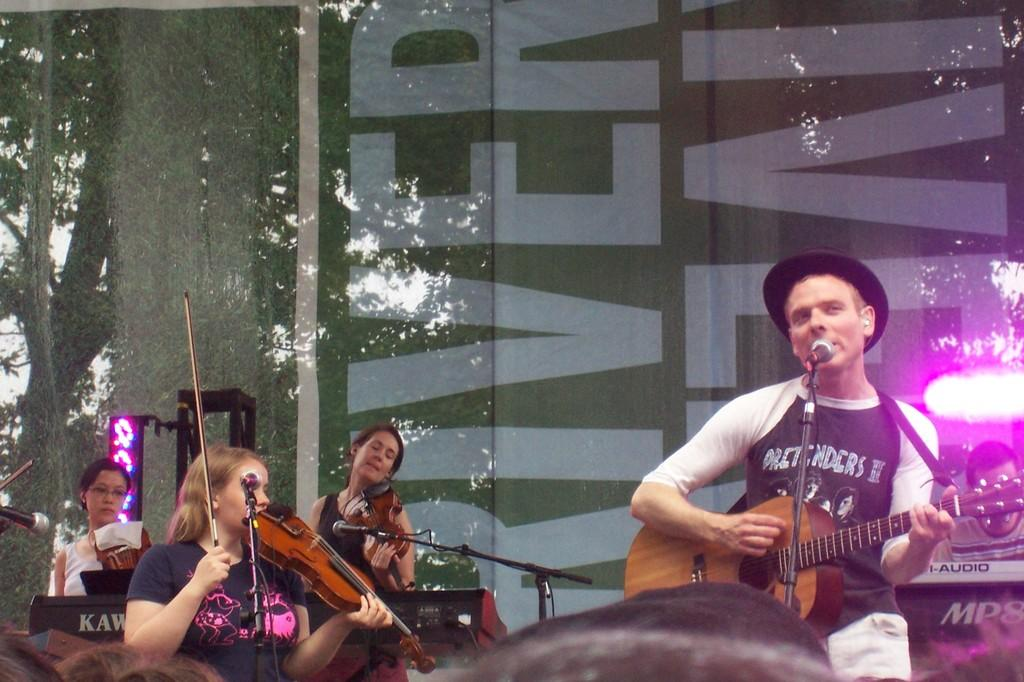What is the person in the image wearing on their head? The person is wearing a black hat in the image. What is the person doing while wearing the hat? The person is singing and playing a guitar. Who else is playing musical instruments in the image? There are three ladies playing violins in the image. What is the person using to amplify their voice? There is a microphone in the image. Who is present to listen to the music being played? There is a group of audience in the image. What type of cakes are being served to the audience in the image? There is no mention of cakes or any food being served in the image. 